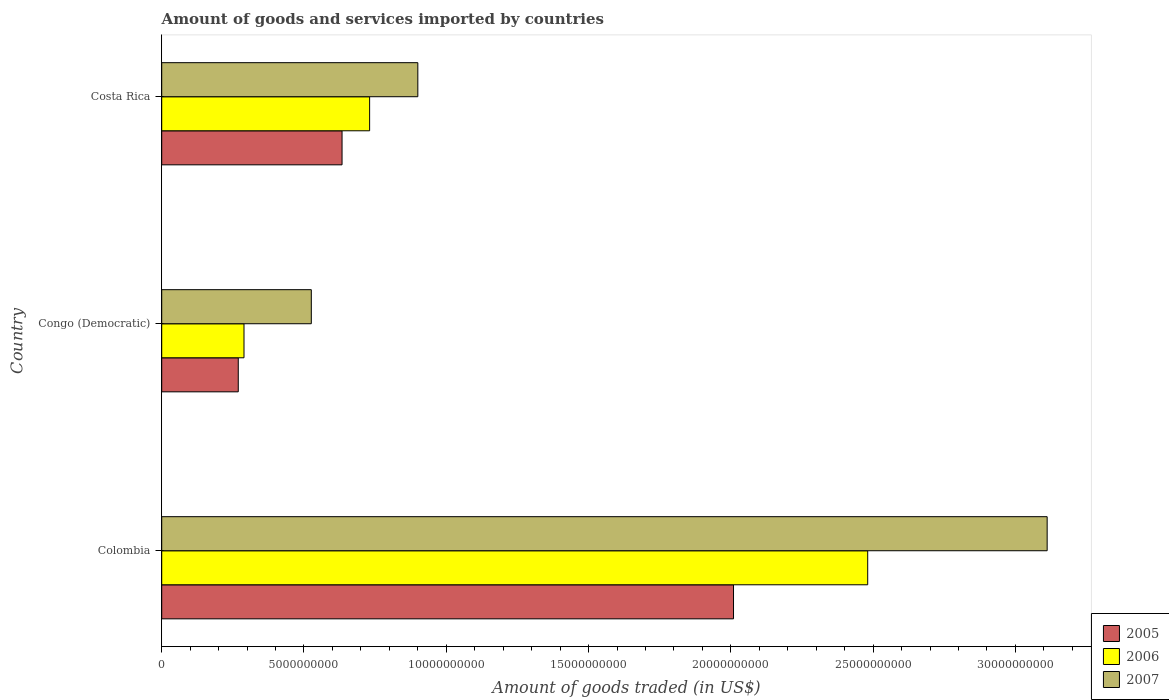How many different coloured bars are there?
Provide a succinct answer. 3. Are the number of bars per tick equal to the number of legend labels?
Provide a short and direct response. Yes. How many bars are there on the 2nd tick from the bottom?
Offer a very short reply. 3. What is the label of the 3rd group of bars from the top?
Offer a terse response. Colombia. In how many cases, is the number of bars for a given country not equal to the number of legend labels?
Make the answer very short. 0. What is the total amount of goods and services imported in 2006 in Congo (Democratic)?
Provide a short and direct response. 2.89e+09. Across all countries, what is the maximum total amount of goods and services imported in 2007?
Offer a very short reply. 3.11e+1. Across all countries, what is the minimum total amount of goods and services imported in 2005?
Ensure brevity in your answer.  2.69e+09. In which country was the total amount of goods and services imported in 2006 maximum?
Offer a very short reply. Colombia. In which country was the total amount of goods and services imported in 2005 minimum?
Give a very brief answer. Congo (Democratic). What is the total total amount of goods and services imported in 2005 in the graph?
Make the answer very short. 2.91e+1. What is the difference between the total amount of goods and services imported in 2006 in Congo (Democratic) and that in Costa Rica?
Give a very brief answer. -4.41e+09. What is the difference between the total amount of goods and services imported in 2005 in Congo (Democratic) and the total amount of goods and services imported in 2007 in Colombia?
Ensure brevity in your answer.  -2.84e+1. What is the average total amount of goods and services imported in 2005 per country?
Make the answer very short. 9.71e+09. What is the difference between the total amount of goods and services imported in 2006 and total amount of goods and services imported in 2007 in Costa Rica?
Your answer should be compact. -1.69e+09. In how many countries, is the total amount of goods and services imported in 2005 greater than 2000000000 US$?
Your response must be concise. 3. What is the ratio of the total amount of goods and services imported in 2005 in Congo (Democratic) to that in Costa Rica?
Provide a succinct answer. 0.42. Is the total amount of goods and services imported in 2006 in Colombia less than that in Costa Rica?
Provide a succinct answer. No. What is the difference between the highest and the second highest total amount of goods and services imported in 2006?
Make the answer very short. 1.75e+1. What is the difference between the highest and the lowest total amount of goods and services imported in 2006?
Provide a short and direct response. 2.19e+1. In how many countries, is the total amount of goods and services imported in 2005 greater than the average total amount of goods and services imported in 2005 taken over all countries?
Your answer should be very brief. 1. Is the sum of the total amount of goods and services imported in 2006 in Colombia and Congo (Democratic) greater than the maximum total amount of goods and services imported in 2007 across all countries?
Your answer should be compact. No. What does the 3rd bar from the top in Colombia represents?
Your answer should be compact. 2005. Is it the case that in every country, the sum of the total amount of goods and services imported in 2005 and total amount of goods and services imported in 2007 is greater than the total amount of goods and services imported in 2006?
Offer a very short reply. Yes. How many countries are there in the graph?
Provide a succinct answer. 3. What is the difference between two consecutive major ticks on the X-axis?
Make the answer very short. 5.00e+09. Does the graph contain any zero values?
Make the answer very short. No. Does the graph contain grids?
Offer a terse response. No. How are the legend labels stacked?
Provide a short and direct response. Vertical. What is the title of the graph?
Ensure brevity in your answer.  Amount of goods and services imported by countries. What is the label or title of the X-axis?
Offer a terse response. Amount of goods traded (in US$). What is the Amount of goods traded (in US$) of 2005 in Colombia?
Your answer should be compact. 2.01e+1. What is the Amount of goods traded (in US$) of 2006 in Colombia?
Offer a very short reply. 2.48e+1. What is the Amount of goods traded (in US$) of 2007 in Colombia?
Offer a very short reply. 3.11e+1. What is the Amount of goods traded (in US$) in 2005 in Congo (Democratic)?
Ensure brevity in your answer.  2.69e+09. What is the Amount of goods traded (in US$) in 2006 in Congo (Democratic)?
Ensure brevity in your answer.  2.89e+09. What is the Amount of goods traded (in US$) of 2007 in Congo (Democratic)?
Offer a terse response. 5.26e+09. What is the Amount of goods traded (in US$) in 2005 in Costa Rica?
Ensure brevity in your answer.  6.34e+09. What is the Amount of goods traded (in US$) of 2006 in Costa Rica?
Your answer should be compact. 7.31e+09. What is the Amount of goods traded (in US$) in 2007 in Costa Rica?
Offer a very short reply. 9.00e+09. Across all countries, what is the maximum Amount of goods traded (in US$) of 2005?
Your answer should be compact. 2.01e+1. Across all countries, what is the maximum Amount of goods traded (in US$) of 2006?
Your response must be concise. 2.48e+1. Across all countries, what is the maximum Amount of goods traded (in US$) in 2007?
Keep it short and to the point. 3.11e+1. Across all countries, what is the minimum Amount of goods traded (in US$) of 2005?
Keep it short and to the point. 2.69e+09. Across all countries, what is the minimum Amount of goods traded (in US$) in 2006?
Give a very brief answer. 2.89e+09. Across all countries, what is the minimum Amount of goods traded (in US$) of 2007?
Give a very brief answer. 5.26e+09. What is the total Amount of goods traded (in US$) in 2005 in the graph?
Provide a short and direct response. 2.91e+1. What is the total Amount of goods traded (in US$) of 2006 in the graph?
Your answer should be compact. 3.50e+1. What is the total Amount of goods traded (in US$) in 2007 in the graph?
Offer a very short reply. 4.54e+1. What is the difference between the Amount of goods traded (in US$) of 2005 in Colombia and that in Congo (Democratic)?
Give a very brief answer. 1.74e+1. What is the difference between the Amount of goods traded (in US$) in 2006 in Colombia and that in Congo (Democratic)?
Give a very brief answer. 2.19e+1. What is the difference between the Amount of goods traded (in US$) of 2007 in Colombia and that in Congo (Democratic)?
Provide a succinct answer. 2.59e+1. What is the difference between the Amount of goods traded (in US$) of 2005 in Colombia and that in Costa Rica?
Your answer should be very brief. 1.38e+1. What is the difference between the Amount of goods traded (in US$) of 2006 in Colombia and that in Costa Rica?
Offer a terse response. 1.75e+1. What is the difference between the Amount of goods traded (in US$) in 2007 in Colombia and that in Costa Rica?
Offer a very short reply. 2.21e+1. What is the difference between the Amount of goods traded (in US$) in 2005 in Congo (Democratic) and that in Costa Rica?
Your answer should be compact. -3.65e+09. What is the difference between the Amount of goods traded (in US$) of 2006 in Congo (Democratic) and that in Costa Rica?
Ensure brevity in your answer.  -4.41e+09. What is the difference between the Amount of goods traded (in US$) in 2007 in Congo (Democratic) and that in Costa Rica?
Keep it short and to the point. -3.74e+09. What is the difference between the Amount of goods traded (in US$) of 2005 in Colombia and the Amount of goods traded (in US$) of 2006 in Congo (Democratic)?
Give a very brief answer. 1.72e+1. What is the difference between the Amount of goods traded (in US$) in 2005 in Colombia and the Amount of goods traded (in US$) in 2007 in Congo (Democratic)?
Your answer should be compact. 1.48e+1. What is the difference between the Amount of goods traded (in US$) in 2006 in Colombia and the Amount of goods traded (in US$) in 2007 in Congo (Democratic)?
Give a very brief answer. 1.96e+1. What is the difference between the Amount of goods traded (in US$) of 2005 in Colombia and the Amount of goods traded (in US$) of 2006 in Costa Rica?
Offer a terse response. 1.28e+1. What is the difference between the Amount of goods traded (in US$) in 2005 in Colombia and the Amount of goods traded (in US$) in 2007 in Costa Rica?
Keep it short and to the point. 1.11e+1. What is the difference between the Amount of goods traded (in US$) in 2006 in Colombia and the Amount of goods traded (in US$) in 2007 in Costa Rica?
Provide a succinct answer. 1.58e+1. What is the difference between the Amount of goods traded (in US$) of 2005 in Congo (Democratic) and the Amount of goods traded (in US$) of 2006 in Costa Rica?
Provide a succinct answer. -4.62e+09. What is the difference between the Amount of goods traded (in US$) of 2005 in Congo (Democratic) and the Amount of goods traded (in US$) of 2007 in Costa Rica?
Keep it short and to the point. -6.31e+09. What is the difference between the Amount of goods traded (in US$) of 2006 in Congo (Democratic) and the Amount of goods traded (in US$) of 2007 in Costa Rica?
Ensure brevity in your answer.  -6.11e+09. What is the average Amount of goods traded (in US$) in 2005 per country?
Ensure brevity in your answer.  9.71e+09. What is the average Amount of goods traded (in US$) in 2006 per country?
Offer a very short reply. 1.17e+1. What is the average Amount of goods traded (in US$) of 2007 per country?
Offer a very short reply. 1.51e+1. What is the difference between the Amount of goods traded (in US$) of 2005 and Amount of goods traded (in US$) of 2006 in Colombia?
Ensure brevity in your answer.  -4.72e+09. What is the difference between the Amount of goods traded (in US$) in 2005 and Amount of goods traded (in US$) in 2007 in Colombia?
Your answer should be compact. -1.10e+1. What is the difference between the Amount of goods traded (in US$) of 2006 and Amount of goods traded (in US$) of 2007 in Colombia?
Your response must be concise. -6.31e+09. What is the difference between the Amount of goods traded (in US$) in 2005 and Amount of goods traded (in US$) in 2006 in Congo (Democratic)?
Give a very brief answer. -2.01e+08. What is the difference between the Amount of goods traded (in US$) of 2005 and Amount of goods traded (in US$) of 2007 in Congo (Democratic)?
Your response must be concise. -2.57e+09. What is the difference between the Amount of goods traded (in US$) of 2006 and Amount of goods traded (in US$) of 2007 in Congo (Democratic)?
Give a very brief answer. -2.37e+09. What is the difference between the Amount of goods traded (in US$) of 2005 and Amount of goods traded (in US$) of 2006 in Costa Rica?
Your response must be concise. -9.69e+08. What is the difference between the Amount of goods traded (in US$) in 2005 and Amount of goods traded (in US$) in 2007 in Costa Rica?
Provide a succinct answer. -2.66e+09. What is the difference between the Amount of goods traded (in US$) in 2006 and Amount of goods traded (in US$) in 2007 in Costa Rica?
Make the answer very short. -1.69e+09. What is the ratio of the Amount of goods traded (in US$) in 2005 in Colombia to that in Congo (Democratic)?
Offer a very short reply. 7.47. What is the ratio of the Amount of goods traded (in US$) in 2006 in Colombia to that in Congo (Democratic)?
Your answer should be compact. 8.58. What is the ratio of the Amount of goods traded (in US$) of 2007 in Colombia to that in Congo (Democratic)?
Your answer should be very brief. 5.92. What is the ratio of the Amount of goods traded (in US$) of 2005 in Colombia to that in Costa Rica?
Keep it short and to the point. 3.17. What is the ratio of the Amount of goods traded (in US$) of 2006 in Colombia to that in Costa Rica?
Your response must be concise. 3.4. What is the ratio of the Amount of goods traded (in US$) in 2007 in Colombia to that in Costa Rica?
Ensure brevity in your answer.  3.46. What is the ratio of the Amount of goods traded (in US$) in 2005 in Congo (Democratic) to that in Costa Rica?
Give a very brief answer. 0.42. What is the ratio of the Amount of goods traded (in US$) in 2006 in Congo (Democratic) to that in Costa Rica?
Provide a succinct answer. 0.4. What is the ratio of the Amount of goods traded (in US$) in 2007 in Congo (Democratic) to that in Costa Rica?
Offer a very short reply. 0.58. What is the difference between the highest and the second highest Amount of goods traded (in US$) in 2005?
Provide a short and direct response. 1.38e+1. What is the difference between the highest and the second highest Amount of goods traded (in US$) in 2006?
Ensure brevity in your answer.  1.75e+1. What is the difference between the highest and the second highest Amount of goods traded (in US$) in 2007?
Give a very brief answer. 2.21e+1. What is the difference between the highest and the lowest Amount of goods traded (in US$) in 2005?
Offer a very short reply. 1.74e+1. What is the difference between the highest and the lowest Amount of goods traded (in US$) in 2006?
Ensure brevity in your answer.  2.19e+1. What is the difference between the highest and the lowest Amount of goods traded (in US$) of 2007?
Ensure brevity in your answer.  2.59e+1. 